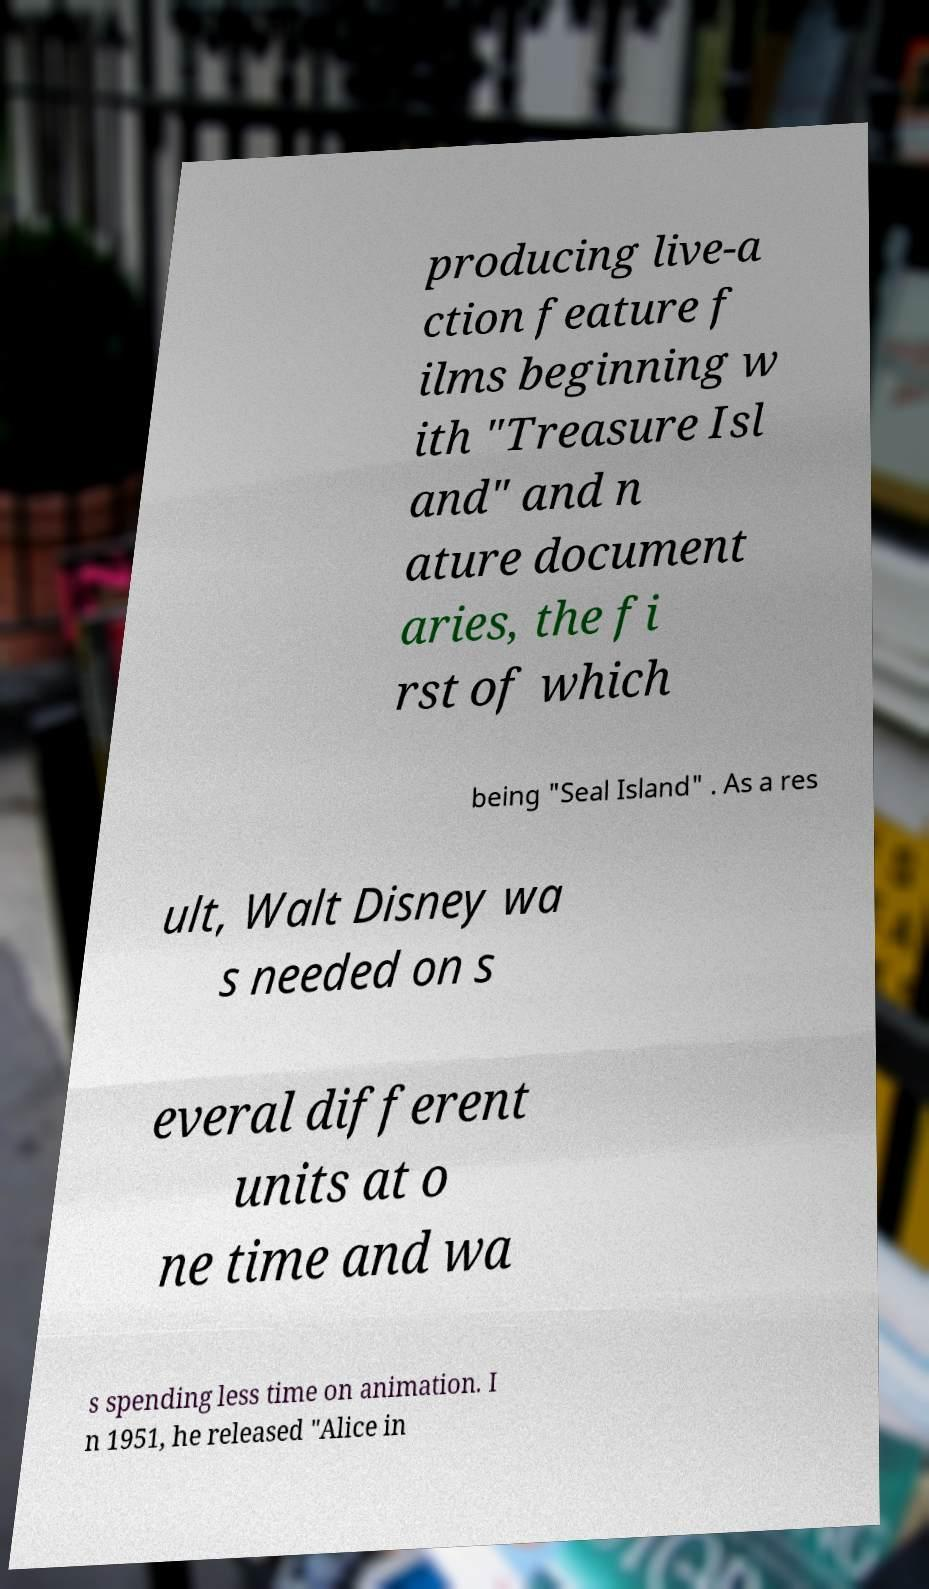Can you accurately transcribe the text from the provided image for me? producing live-a ction feature f ilms beginning w ith "Treasure Isl and" and n ature document aries, the fi rst of which being "Seal Island" . As a res ult, Walt Disney wa s needed on s everal different units at o ne time and wa s spending less time on animation. I n 1951, he released "Alice in 